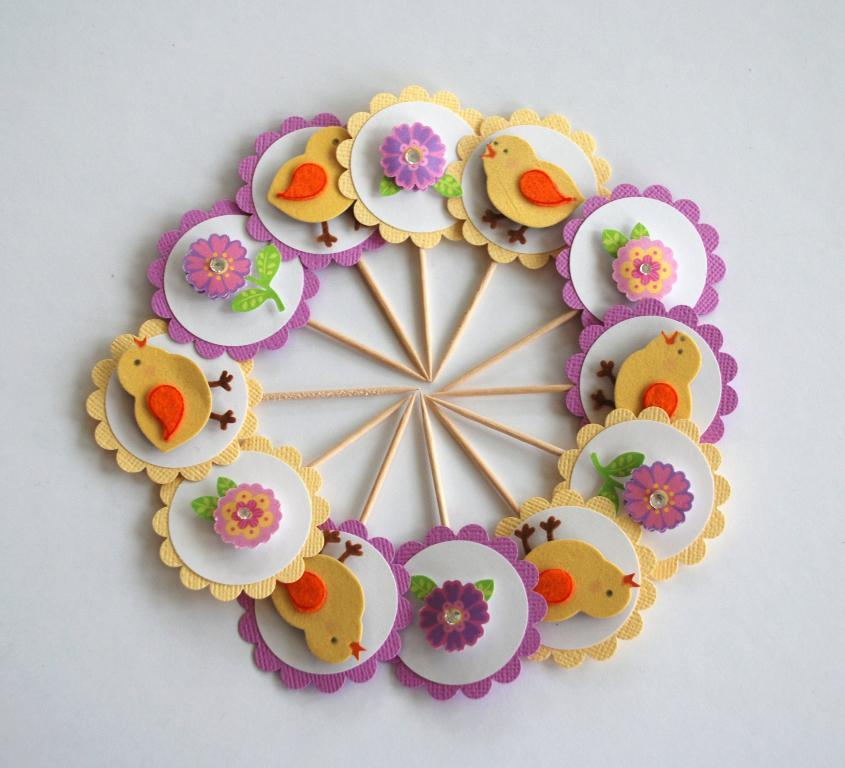What type of design is featured in the image? The image contains an art and craft design. How many tickets are visible in the image? There are no tickets present in the image; it features an art and craft design. What type of calendar is shown in the image? There is no calendar present in the image; it features an art and craft design. 